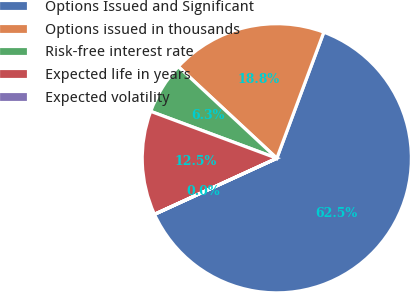Convert chart to OTSL. <chart><loc_0><loc_0><loc_500><loc_500><pie_chart><fcel>Options Issued and Significant<fcel>Options issued in thousands<fcel>Risk-free interest rate<fcel>Expected life in years<fcel>Expected volatility<nl><fcel>62.48%<fcel>18.75%<fcel>6.26%<fcel>12.5%<fcel>0.01%<nl></chart> 